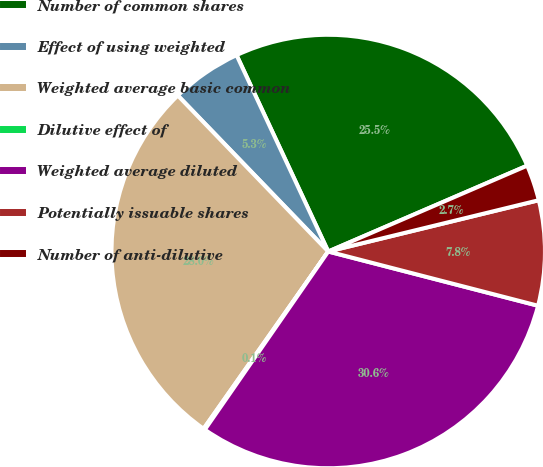Convert chart. <chart><loc_0><loc_0><loc_500><loc_500><pie_chart><fcel>Number of common shares<fcel>Effect of using weighted<fcel>Weighted average basic common<fcel>Dilutive effect of<fcel>Weighted average diluted<fcel>Potentially issuable shares<fcel>Number of anti-dilutive<nl><fcel>25.47%<fcel>5.26%<fcel>28.04%<fcel>0.11%<fcel>30.62%<fcel>7.83%<fcel>2.68%<nl></chart> 